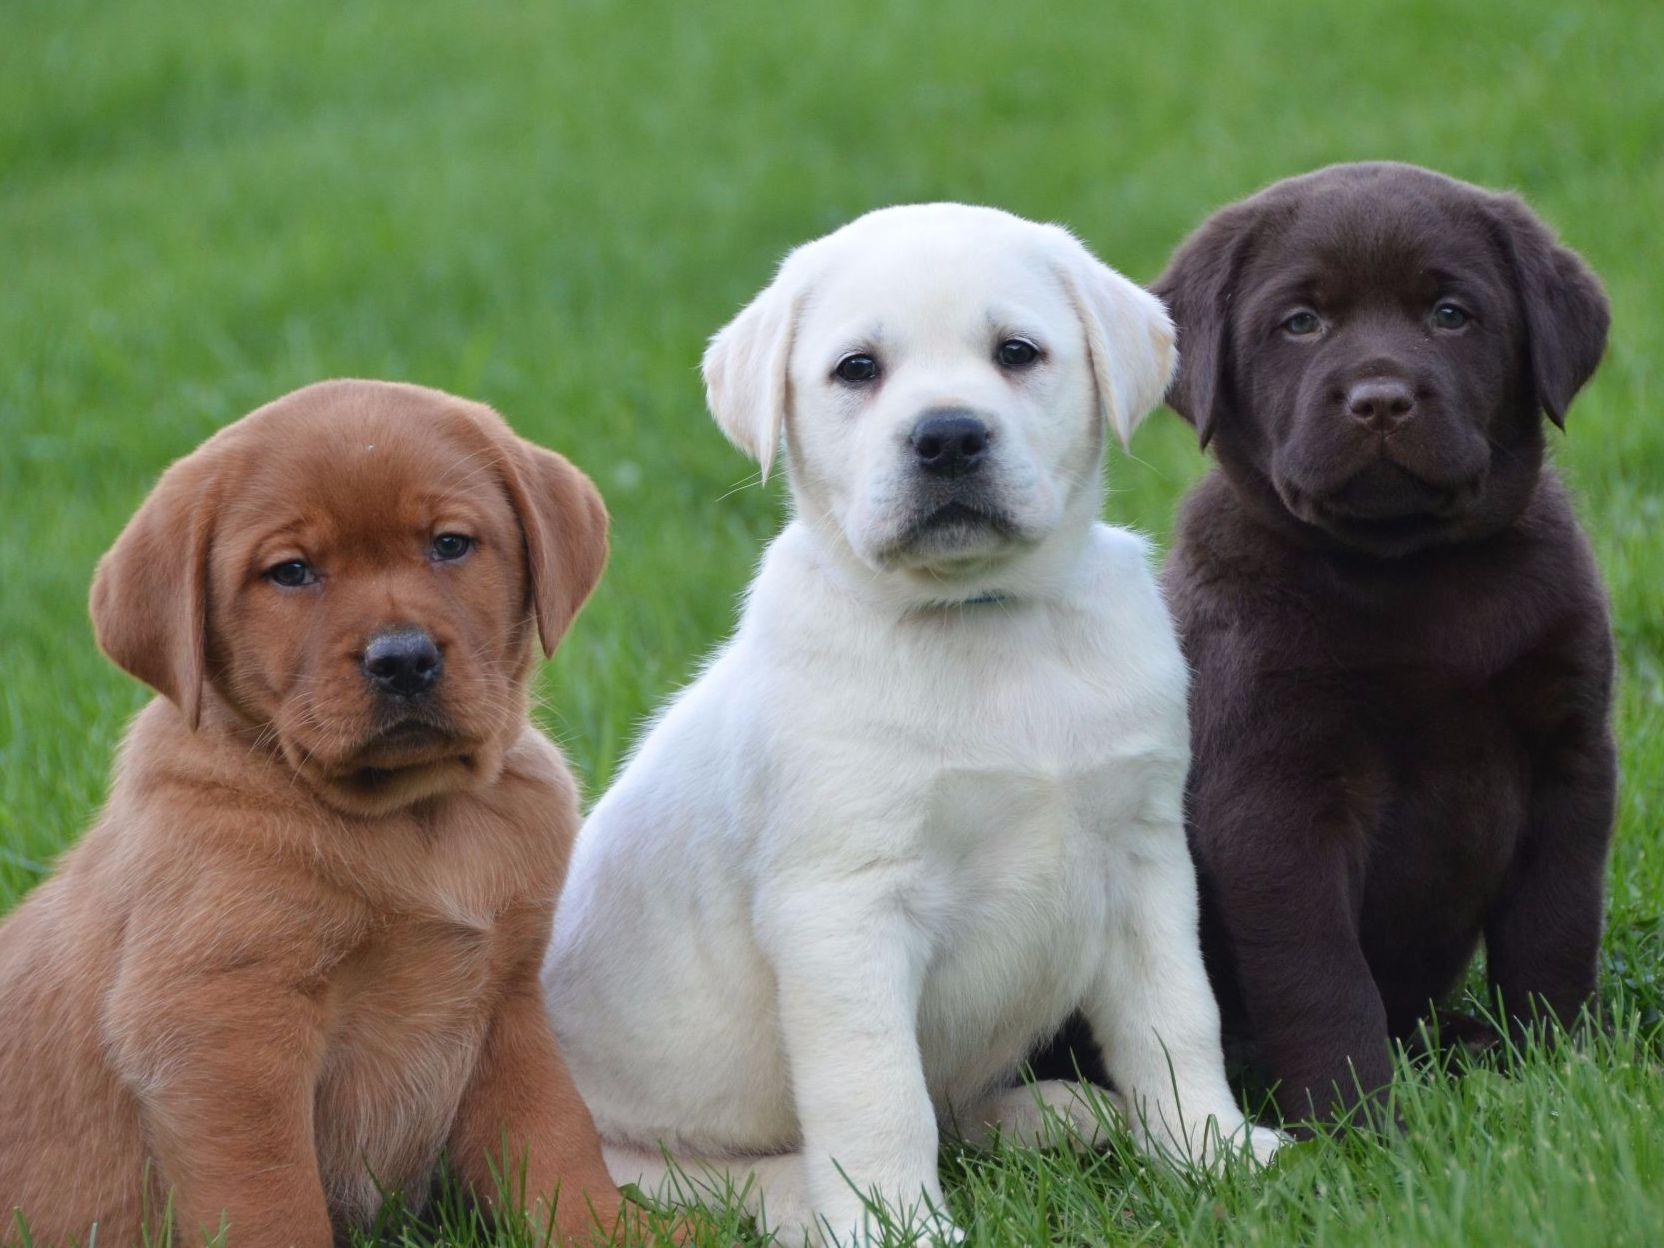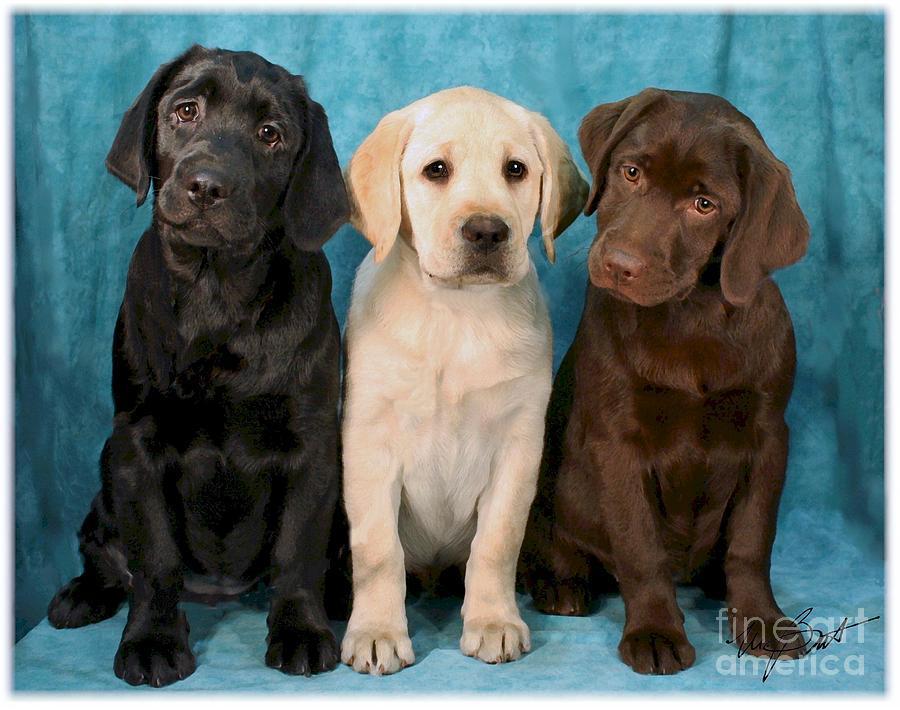The first image is the image on the left, the second image is the image on the right. Considering the images on both sides, is "An image shows three upright, non-reclining dogs posed with the black dog on the far left and the brown dog on the far right." valid? Answer yes or no. Yes. The first image is the image on the left, the second image is the image on the right. Considering the images on both sides, is "6 dogs exactly can be seen." valid? Answer yes or no. Yes. 